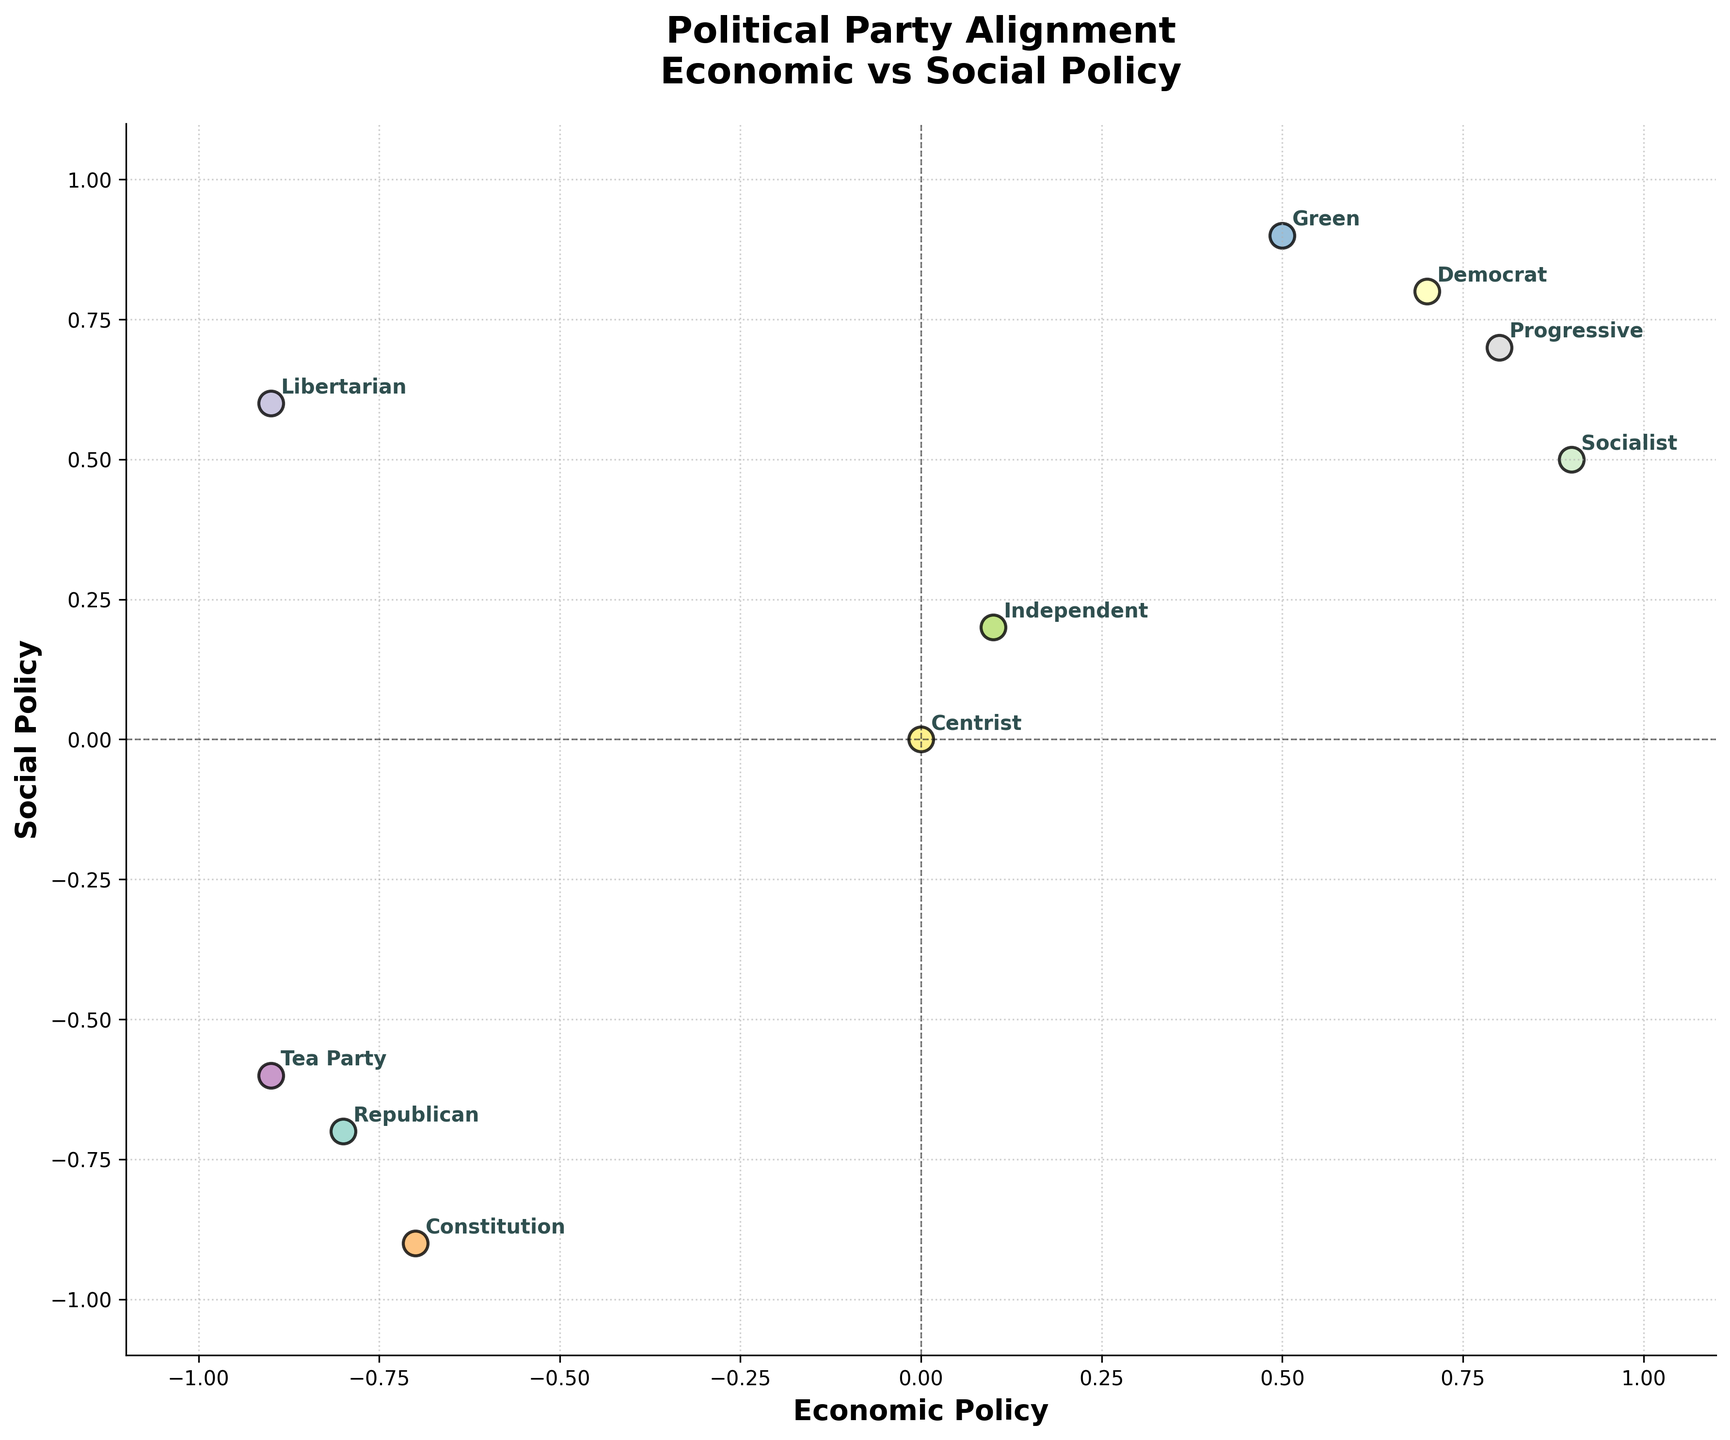What's the title of the figure? The title is usually found at the top of the figure. It provides the context and subject matter, making it one of the most straightforward elements to identify.
Answer: Political Party Alignment\nEconomic vs Social Policy What party is closest to the center of the plot? The center of the plot is where both 'Economic Policy' and 'Social Policy' values are zero. The annotation closest to this point is the 'Centrist' party.
Answer: Centrist Which parties are positioned in the negative quadrant for both Economic and Social Policy? The negative quadrant for both policies is the lower-left section of the plot where both x and y values are negative. The parties in this region are Republication, Constitution, and Tea Party
Answer: Republican, Constitution, Tea Party How many parties have negative values for Economic Policy but positive values for Social Policy? This would be the upper-left quadrant of the plot where x-values are negative and y-values are positive. The parties in this quadrant are Libertarian.
Answer: Libertarian Compare the Green party to the Independent party. Which has a higher Social Policy value? The Social Policy value of Green party is 0.9 whereas for Independent is 0.2. Therefore, Green party has a higher value.
Answer: Green What is the average Social Policy value for Democrat, Progressive, and Socialist parties? The Social Policy values are 0.8 (Democrat), 0.7 (Progressive), and 0.5 (Socialist). Average = (0.8 + 0.7 + 0.5) / 3 = 2.0 / 3 = 0.67
Answer: 0.67 Are there more parties with positive values for Economic Policy or Social Policy? By counting the positive values for both axes, we have five parties with positive Economic Policy values (Democrat, Green, Independent, Progressive, Socialist), and five parties with positive Social Policy values (Democrat, Libertarian, Green, Independent, Progressive). The counts are equal.
Answer: Equal Which party has the most extreme values on both Economic and Social Policy axes? The most extreme values are the farthest from the center, both positively and negatively. Comparing all, the Socialist party has the highest positive values, but Tea Party has the most negative on both axes. So, Tea Party has the most extreme values.
Answer: Tea Party Which quadrant has the fewest number of parties, and which parties are they? The upper-left (negative Economic, positive Social) has only one party, which is Libertarian.
Answer: Upper-left, Libertarian 